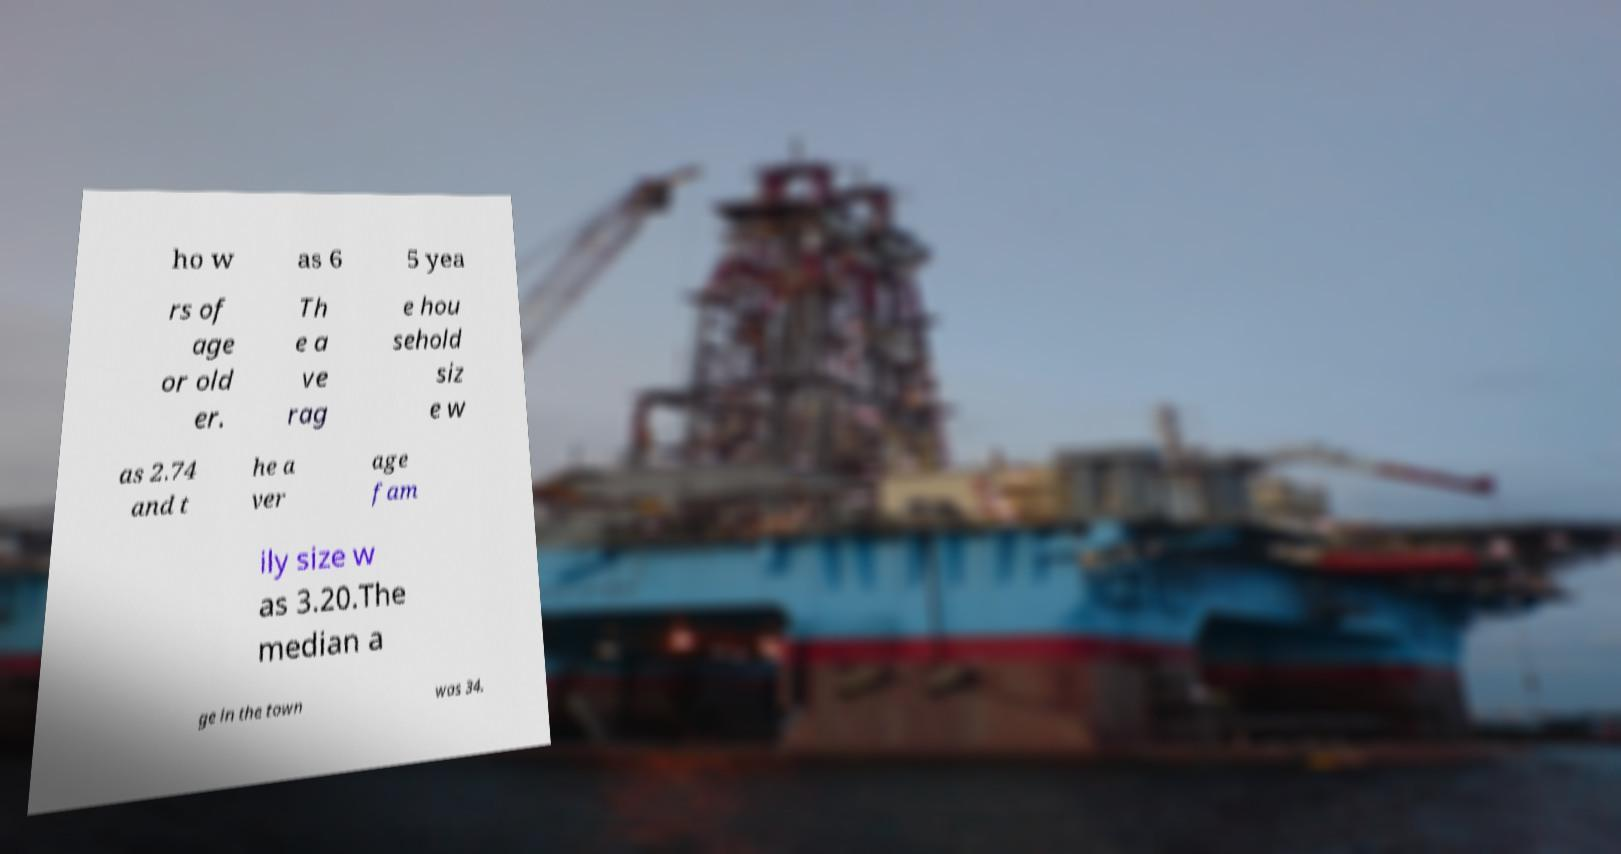What messages or text are displayed in this image? I need them in a readable, typed format. ho w as 6 5 yea rs of age or old er. Th e a ve rag e hou sehold siz e w as 2.74 and t he a ver age fam ily size w as 3.20.The median a ge in the town was 34. 